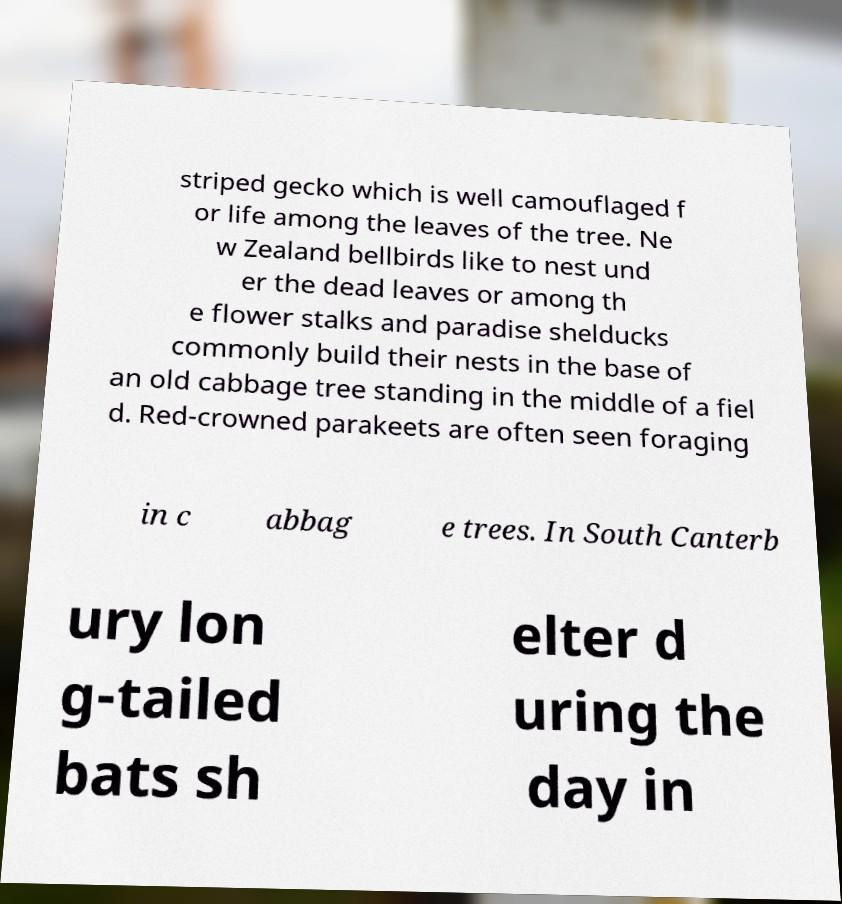Can you read and provide the text displayed in the image?This photo seems to have some interesting text. Can you extract and type it out for me? striped gecko which is well camouflaged f or life among the leaves of the tree. Ne w Zealand bellbirds like to nest und er the dead leaves or among th e flower stalks and paradise shelducks commonly build their nests in the base of an old cabbage tree standing in the middle of a fiel d. Red-crowned parakeets are often seen foraging in c abbag e trees. In South Canterb ury lon g-tailed bats sh elter d uring the day in 